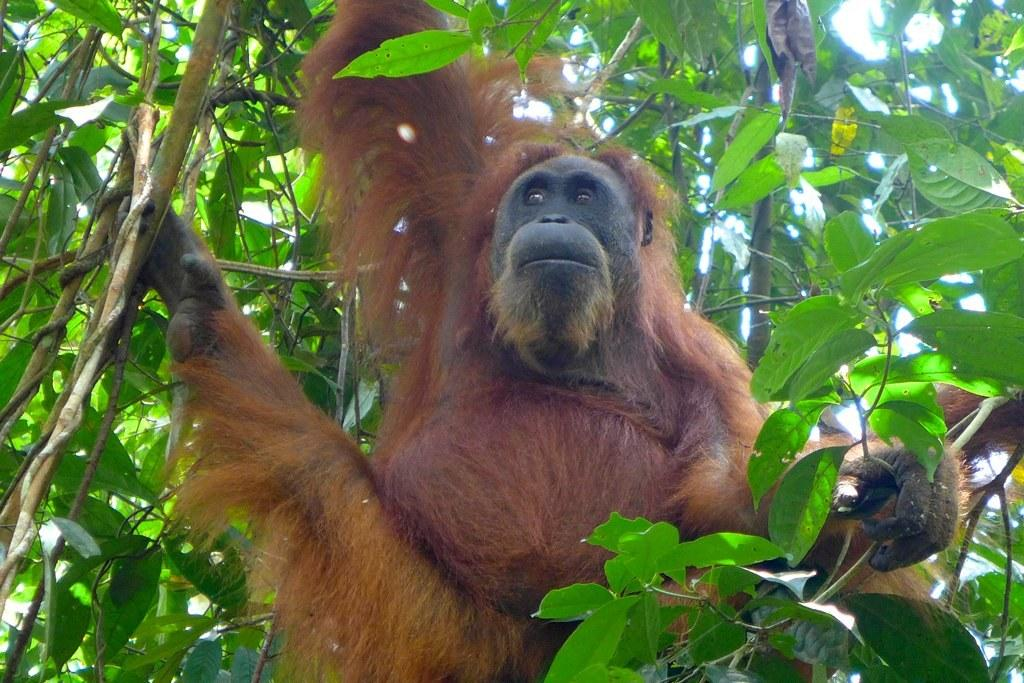What type of animal is in the image? There is a chimpanzee in the image. What is the chimpanzee near in the image? There is a tree in the image. What can be seen in the background of the image? The sky is visible in the background of the image. What type of stitch is used to create the harmony between the chimpanzee and the tree in the image? There is no stitch or concept of harmony between the chimpanzee and the tree in the image. 